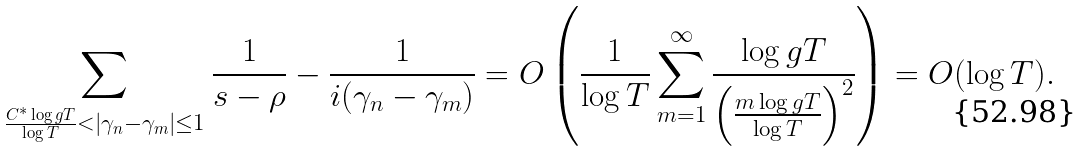<formula> <loc_0><loc_0><loc_500><loc_500>\sum _ { \frac { C ^ { * } \log g T } { \log T } < | \gamma _ { n } - \gamma _ { m } | \leq 1 } \frac { 1 } { s - \rho } - \frac { 1 } { i ( \gamma _ { n } - \gamma _ { m } ) } = O \left ( \frac { 1 } { \log T } \sum _ { m = 1 } ^ { \infty } \frac { \log g T } { \left ( \frac { m \log g T } { \log T } \right ) ^ { 2 } } \right ) = O ( \log T ) .</formula> 